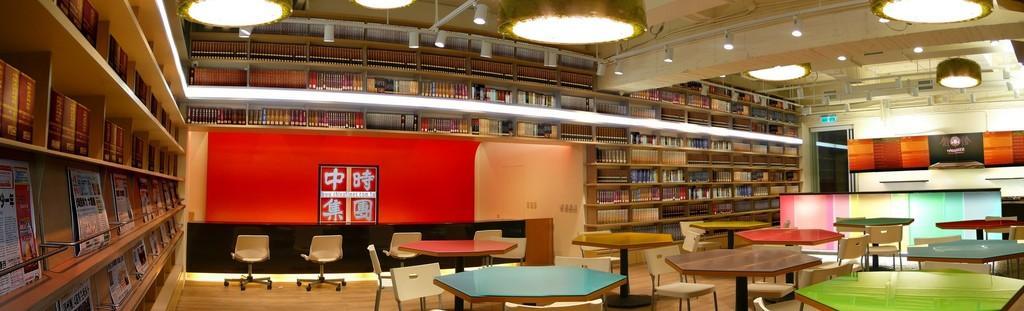How would you summarize this image in a sentence or two? At the top we can see the ceiling and lights. In this picture we can see the books are arranged in the racks. On the left side of the picture we can see the newspapers and books in the racks. We can see chairs, tables, floor and objects. 